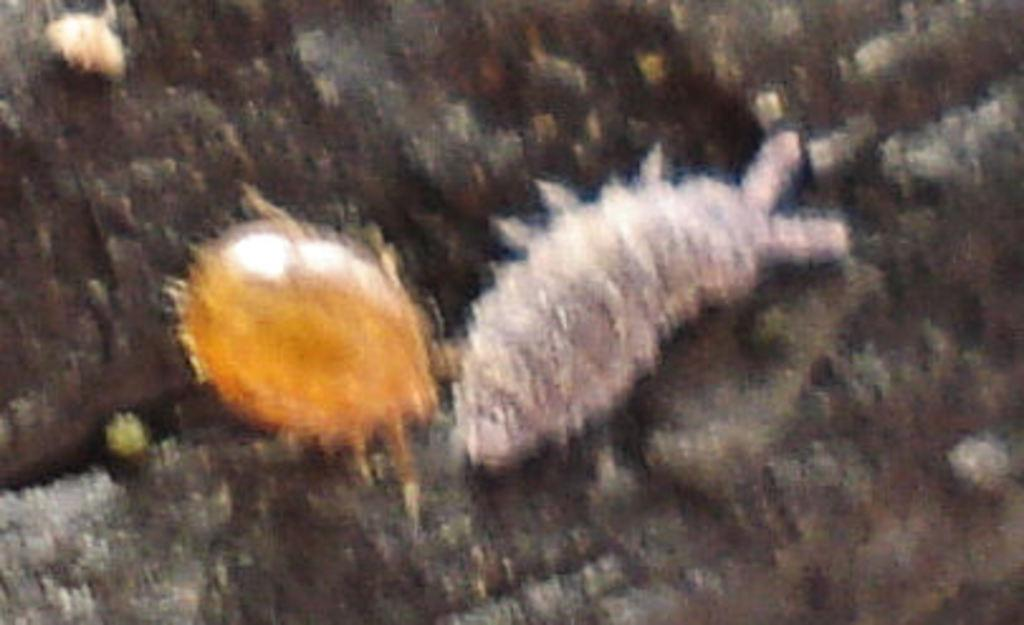What type of living organisms can be seen in the image? Insects can be seen in the image. What type of room can be seen in the image? There is no room present in the image; it features insects. Can you tell me how many volcanoes are visible in the image? There are no volcanoes present in the image; it features insects. 